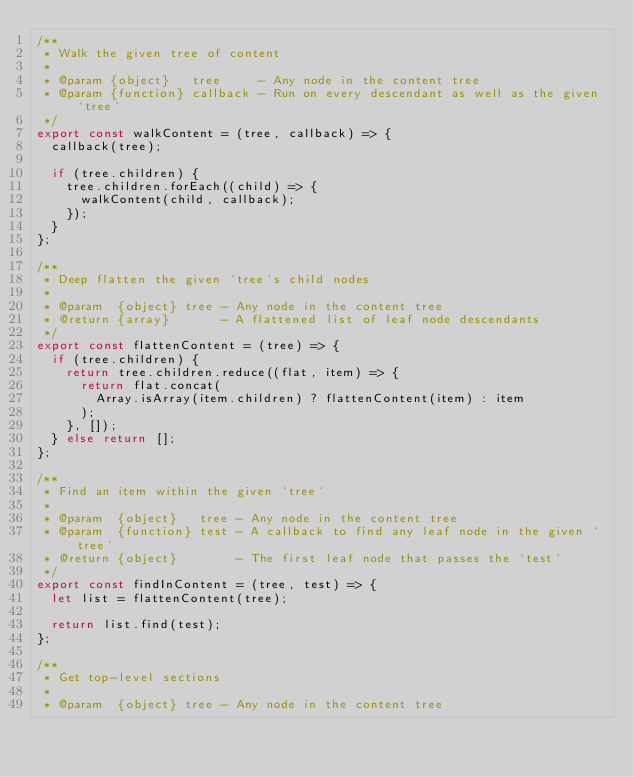Convert code to text. <code><loc_0><loc_0><loc_500><loc_500><_JavaScript_>/**
 * Walk the given tree of content
 *
 * @param {object}   tree     - Any node in the content tree
 * @param {function} callback - Run on every descendant as well as the given `tree`
 */
export const walkContent = (tree, callback) => {
  callback(tree);

  if (tree.children) {
    tree.children.forEach((child) => {
      walkContent(child, callback);
    });
  }
};

/**
 * Deep flatten the given `tree`s child nodes
 *
 * @param  {object} tree - Any node in the content tree
 * @return {array}       - A flattened list of leaf node descendants
 */
export const flattenContent = (tree) => {
  if (tree.children) {
    return tree.children.reduce((flat, item) => {
      return flat.concat(
        Array.isArray(item.children) ? flattenContent(item) : item
      );
    }, []);
  } else return [];
};

/**
 * Find an item within the given `tree`
 *
 * @param  {object}   tree - Any node in the content tree
 * @param  {function} test - A callback to find any leaf node in the given `tree`
 * @return {object}        - The first leaf node that passes the `test`
 */
export const findInContent = (tree, test) => {
  let list = flattenContent(tree);

  return list.find(test);
};

/**
 * Get top-level sections
 *
 * @param  {object} tree - Any node in the content tree</code> 